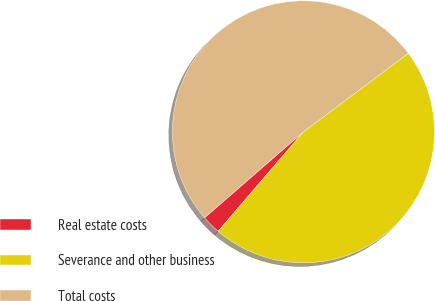Convert chart. <chart><loc_0><loc_0><loc_500><loc_500><pie_chart><fcel>Real estate costs<fcel>Severance and other business<fcel>Total costs<nl><fcel>2.33%<fcel>46.51%<fcel>51.16%<nl></chart> 